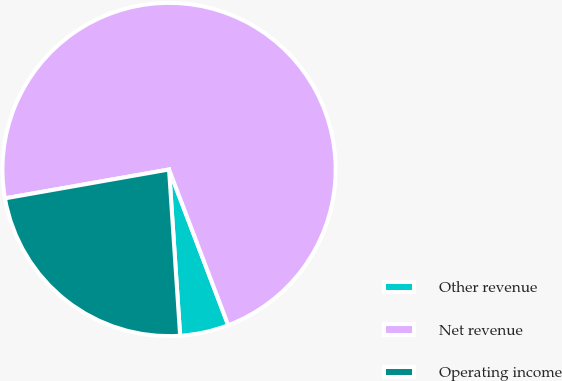Convert chart. <chart><loc_0><loc_0><loc_500><loc_500><pie_chart><fcel>Other revenue<fcel>Net revenue<fcel>Operating income<nl><fcel>4.72%<fcel>71.99%<fcel>23.29%<nl></chart> 